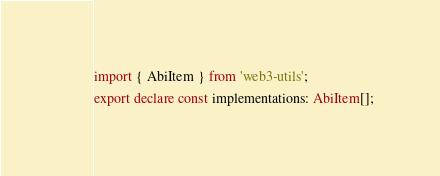Convert code to text. <code><loc_0><loc_0><loc_500><loc_500><_TypeScript_>import { AbiItem } from 'web3-utils';
export declare const implementations: AbiItem[];
</code> 